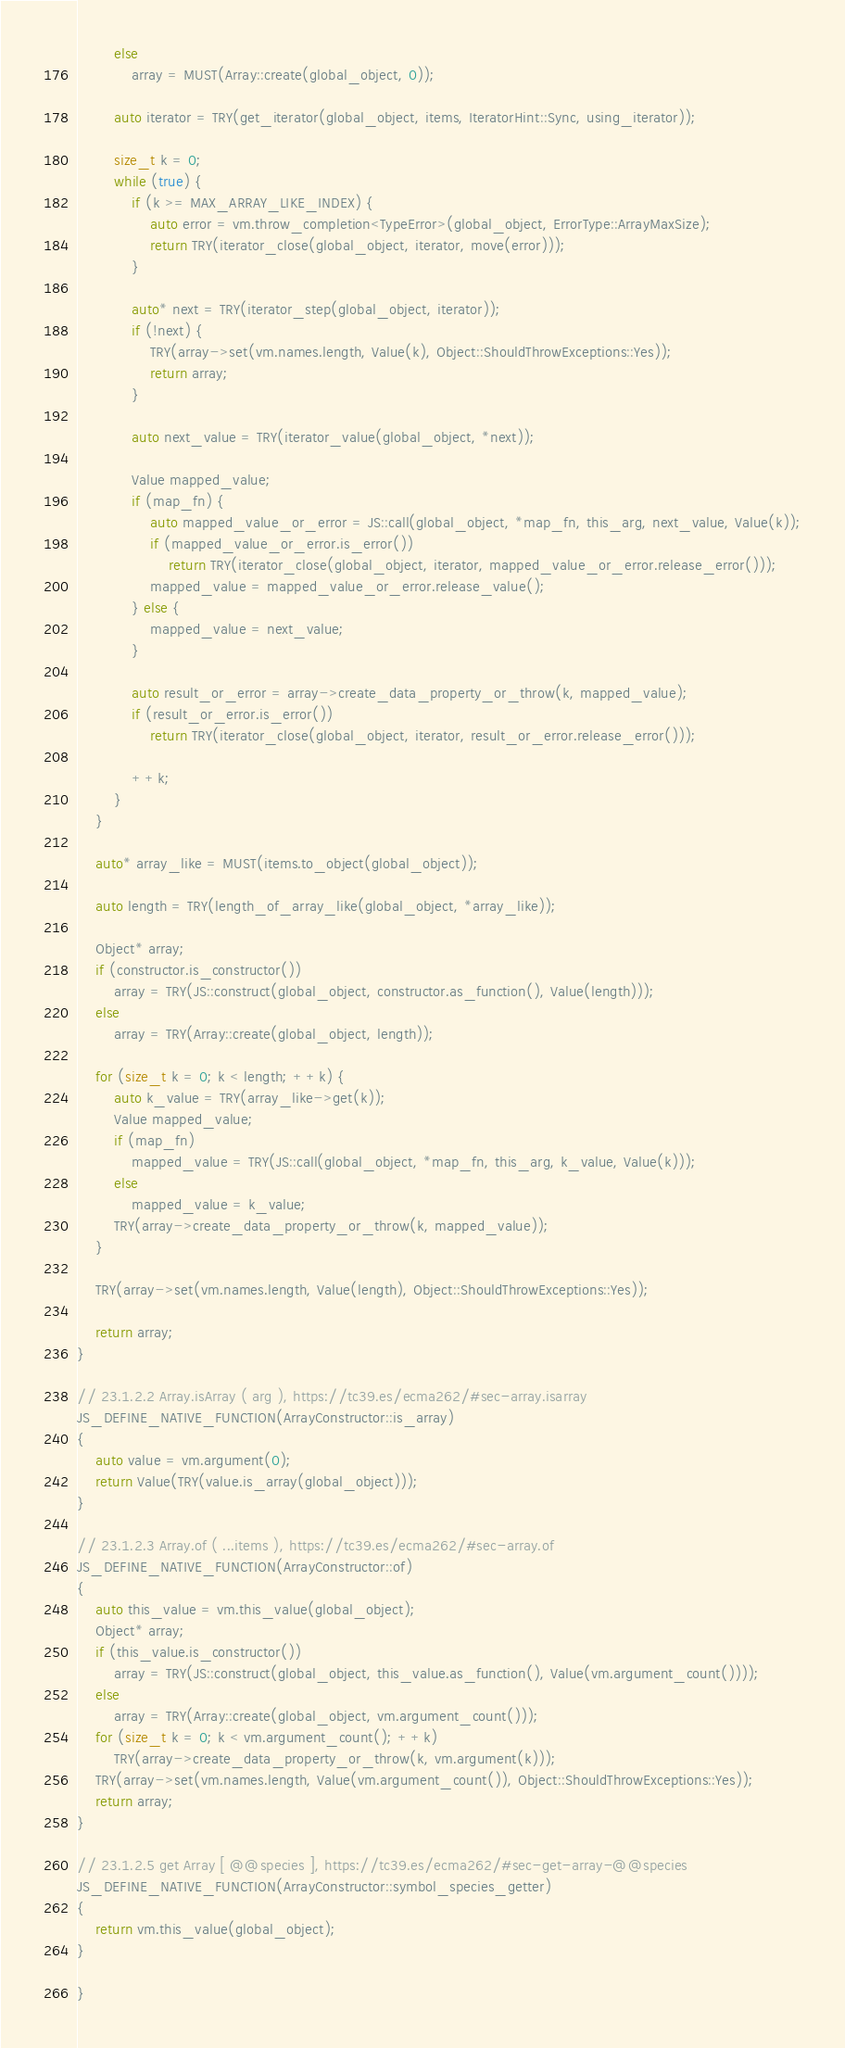Convert code to text. <code><loc_0><loc_0><loc_500><loc_500><_C++_>        else
            array = MUST(Array::create(global_object, 0));

        auto iterator = TRY(get_iterator(global_object, items, IteratorHint::Sync, using_iterator));

        size_t k = 0;
        while (true) {
            if (k >= MAX_ARRAY_LIKE_INDEX) {
                auto error = vm.throw_completion<TypeError>(global_object, ErrorType::ArrayMaxSize);
                return TRY(iterator_close(global_object, iterator, move(error)));
            }

            auto* next = TRY(iterator_step(global_object, iterator));
            if (!next) {
                TRY(array->set(vm.names.length, Value(k), Object::ShouldThrowExceptions::Yes));
                return array;
            }

            auto next_value = TRY(iterator_value(global_object, *next));

            Value mapped_value;
            if (map_fn) {
                auto mapped_value_or_error = JS::call(global_object, *map_fn, this_arg, next_value, Value(k));
                if (mapped_value_or_error.is_error())
                    return TRY(iterator_close(global_object, iterator, mapped_value_or_error.release_error()));
                mapped_value = mapped_value_or_error.release_value();
            } else {
                mapped_value = next_value;
            }

            auto result_or_error = array->create_data_property_or_throw(k, mapped_value);
            if (result_or_error.is_error())
                return TRY(iterator_close(global_object, iterator, result_or_error.release_error()));

            ++k;
        }
    }

    auto* array_like = MUST(items.to_object(global_object));

    auto length = TRY(length_of_array_like(global_object, *array_like));

    Object* array;
    if (constructor.is_constructor())
        array = TRY(JS::construct(global_object, constructor.as_function(), Value(length)));
    else
        array = TRY(Array::create(global_object, length));

    for (size_t k = 0; k < length; ++k) {
        auto k_value = TRY(array_like->get(k));
        Value mapped_value;
        if (map_fn)
            mapped_value = TRY(JS::call(global_object, *map_fn, this_arg, k_value, Value(k)));
        else
            mapped_value = k_value;
        TRY(array->create_data_property_or_throw(k, mapped_value));
    }

    TRY(array->set(vm.names.length, Value(length), Object::ShouldThrowExceptions::Yes));

    return array;
}

// 23.1.2.2 Array.isArray ( arg ), https://tc39.es/ecma262/#sec-array.isarray
JS_DEFINE_NATIVE_FUNCTION(ArrayConstructor::is_array)
{
    auto value = vm.argument(0);
    return Value(TRY(value.is_array(global_object)));
}

// 23.1.2.3 Array.of ( ...items ), https://tc39.es/ecma262/#sec-array.of
JS_DEFINE_NATIVE_FUNCTION(ArrayConstructor::of)
{
    auto this_value = vm.this_value(global_object);
    Object* array;
    if (this_value.is_constructor())
        array = TRY(JS::construct(global_object, this_value.as_function(), Value(vm.argument_count())));
    else
        array = TRY(Array::create(global_object, vm.argument_count()));
    for (size_t k = 0; k < vm.argument_count(); ++k)
        TRY(array->create_data_property_or_throw(k, vm.argument(k)));
    TRY(array->set(vm.names.length, Value(vm.argument_count()), Object::ShouldThrowExceptions::Yes));
    return array;
}

// 23.1.2.5 get Array [ @@species ], https://tc39.es/ecma262/#sec-get-array-@@species
JS_DEFINE_NATIVE_FUNCTION(ArrayConstructor::symbol_species_getter)
{
    return vm.this_value(global_object);
}

}
</code> 